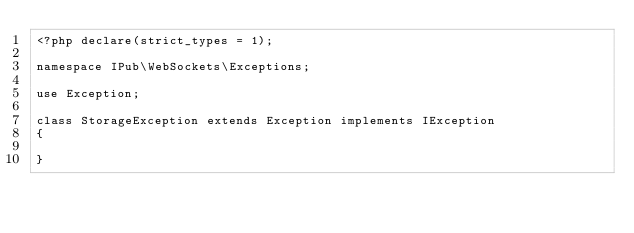Convert code to text. <code><loc_0><loc_0><loc_500><loc_500><_PHP_><?php declare(strict_types = 1);

namespace IPub\WebSockets\Exceptions;

use Exception;

class StorageException extends Exception implements IException
{

}
</code> 